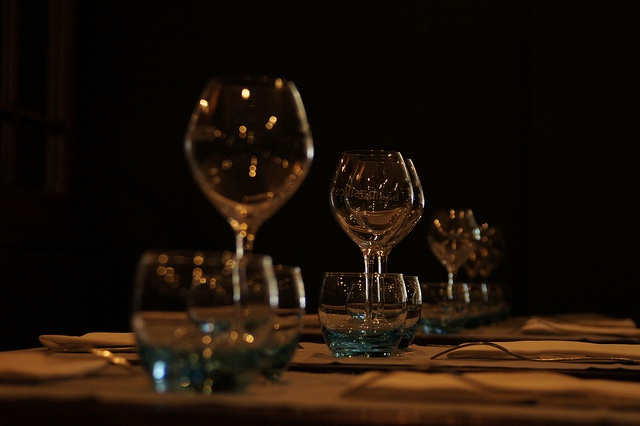Describe the objects in this image and their specific colors. I can see dining table in black, maroon, and brown tones, wine glass in black, maroon, and brown tones, cup in black, maroon, and brown tones, cup in black, maroon, and gray tones, and wine glass in black, maroon, and brown tones in this image. 